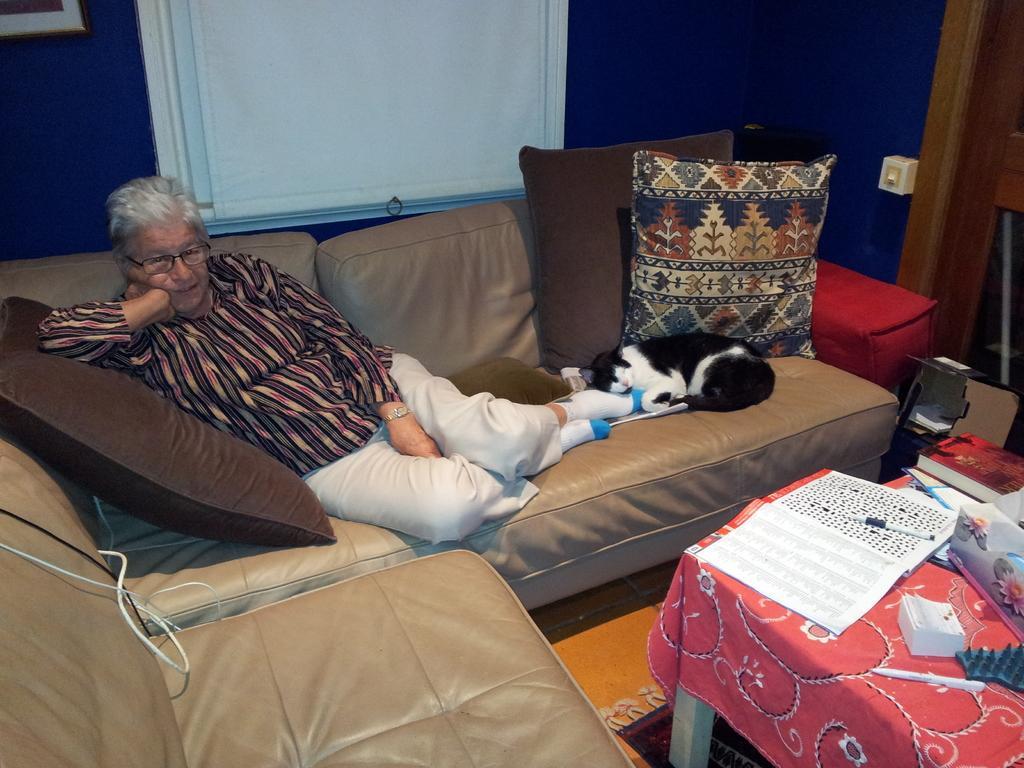Could you give a brief overview of what you see in this image? There is a person and a cat on the sofa. Here we can see pillows, tablecloth, books, and markers. This is floor. In the background we can see a frame and a wall. 